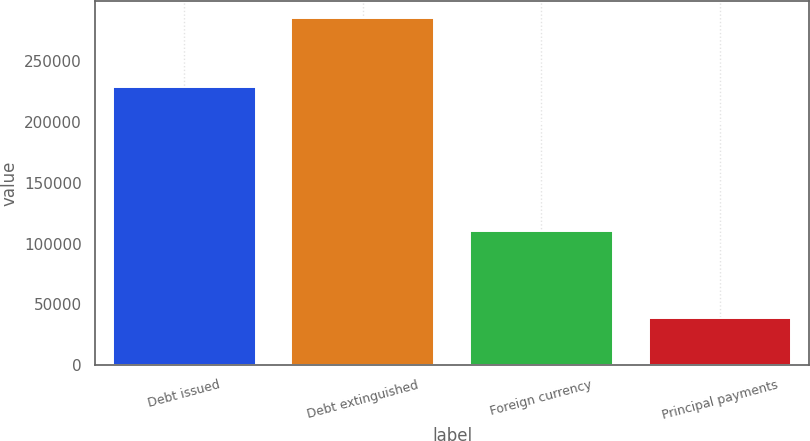Convert chart to OTSL. <chart><loc_0><loc_0><loc_500><loc_500><bar_chart><fcel>Debt issued<fcel>Debt extinguished<fcel>Foreign currency<fcel>Principal payments<nl><fcel>228685<fcel>285599<fcel>110691<fcel>38690<nl></chart> 